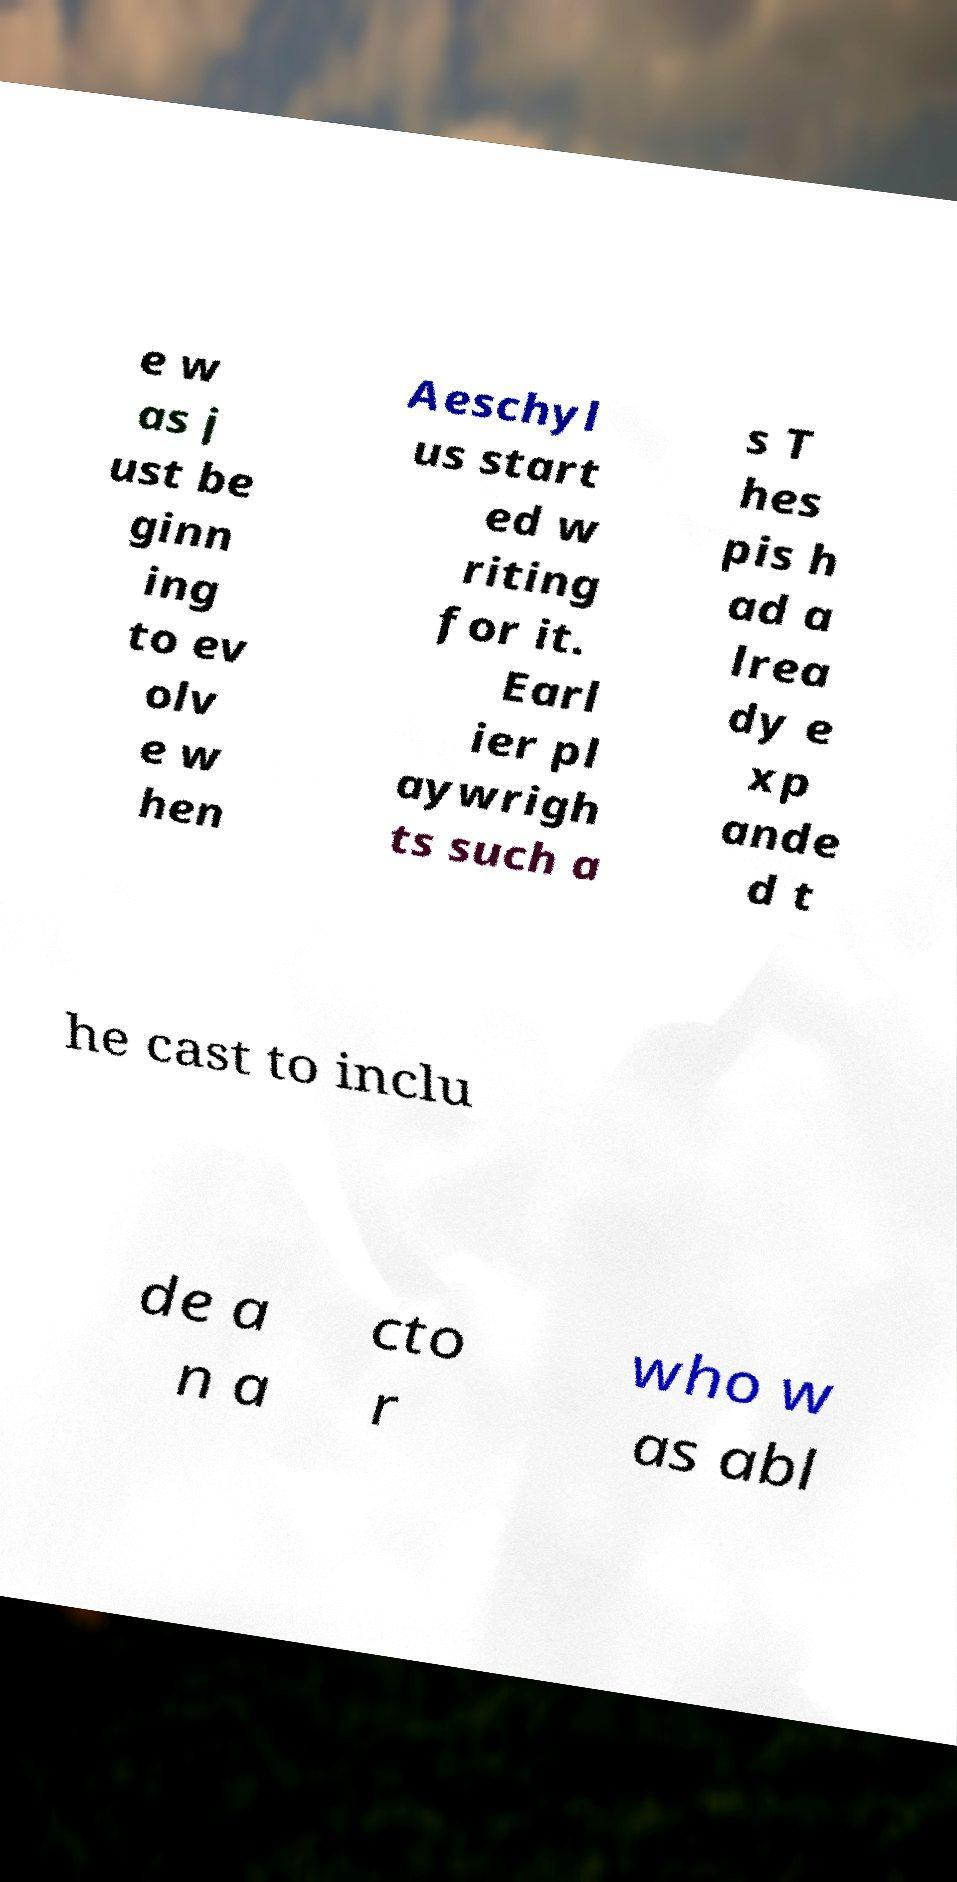Please read and relay the text visible in this image. What does it say? e w as j ust be ginn ing to ev olv e w hen Aeschyl us start ed w riting for it. Earl ier pl aywrigh ts such a s T hes pis h ad a lrea dy e xp ande d t he cast to inclu de a n a cto r who w as abl 